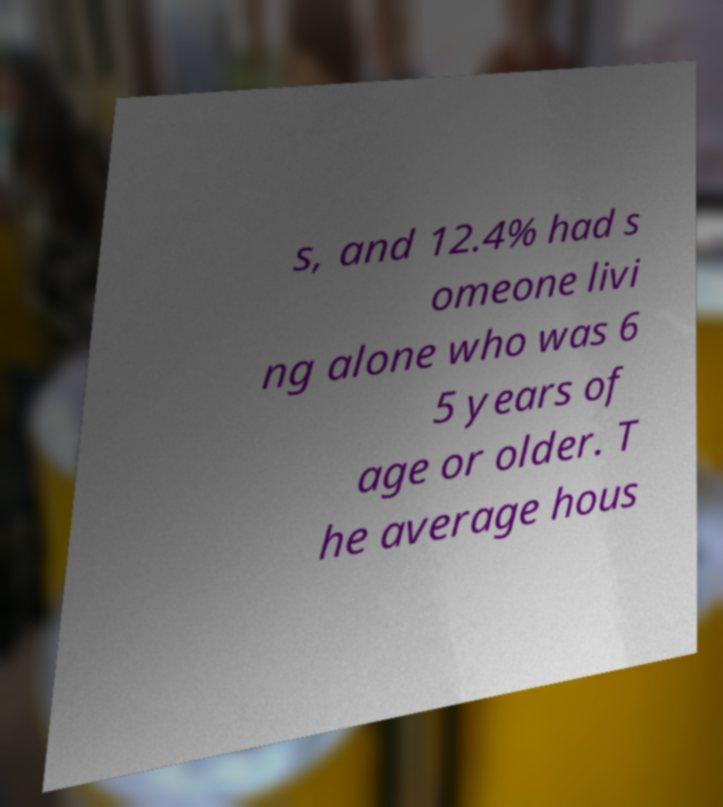Please read and relay the text visible in this image. What does it say? s, and 12.4% had s omeone livi ng alone who was 6 5 years of age or older. T he average hous 